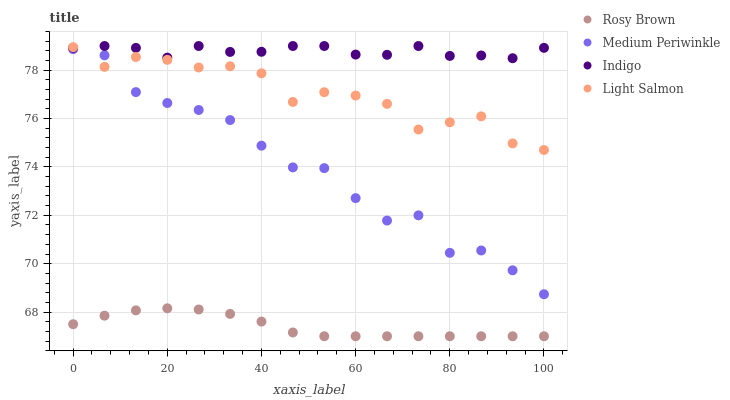Does Rosy Brown have the minimum area under the curve?
Answer yes or no. Yes. Does Indigo have the maximum area under the curve?
Answer yes or no. Yes. Does Light Salmon have the minimum area under the curve?
Answer yes or no. No. Does Light Salmon have the maximum area under the curve?
Answer yes or no. No. Is Rosy Brown the smoothest?
Answer yes or no. Yes. Is Medium Periwinkle the roughest?
Answer yes or no. Yes. Is Light Salmon the smoothest?
Answer yes or no. No. Is Light Salmon the roughest?
Answer yes or no. No. Does Rosy Brown have the lowest value?
Answer yes or no. Yes. Does Light Salmon have the lowest value?
Answer yes or no. No. Does Indigo have the highest value?
Answer yes or no. Yes. Does Light Salmon have the highest value?
Answer yes or no. No. Is Medium Periwinkle less than Indigo?
Answer yes or no. Yes. Is Indigo greater than Rosy Brown?
Answer yes or no. Yes. Does Indigo intersect Light Salmon?
Answer yes or no. Yes. Is Indigo less than Light Salmon?
Answer yes or no. No. Is Indigo greater than Light Salmon?
Answer yes or no. No. Does Medium Periwinkle intersect Indigo?
Answer yes or no. No. 